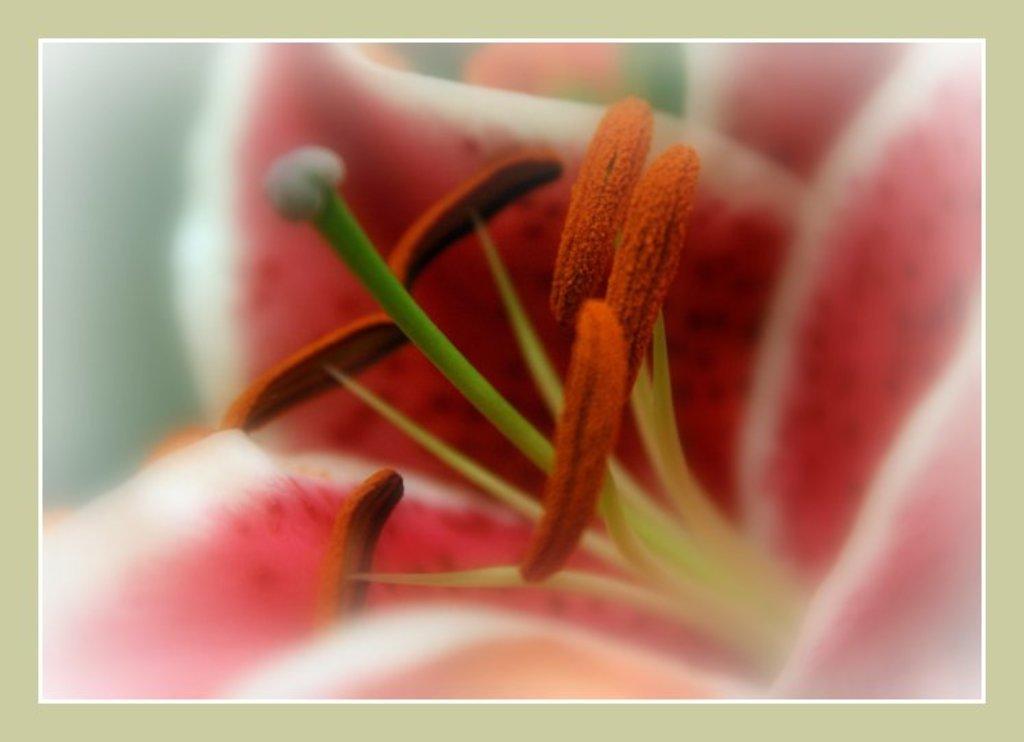Can you describe this image briefly? In this picture, we see a flower which is having stigma and anther. We even see petals which are in pink and white color. 